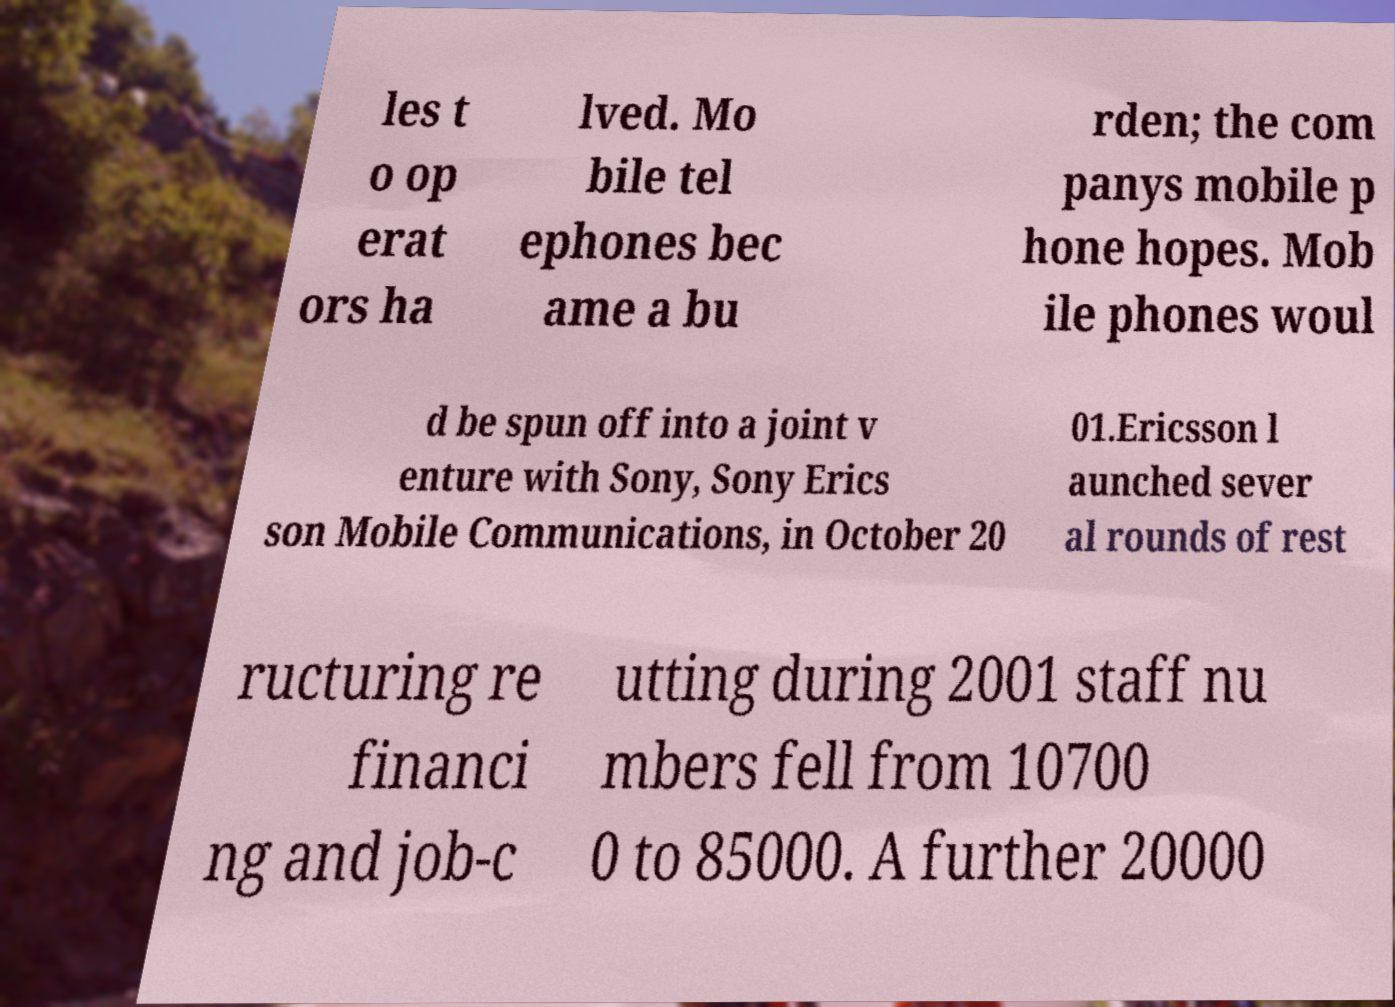Please identify and transcribe the text found in this image. les t o op erat ors ha lved. Mo bile tel ephones bec ame a bu rden; the com panys mobile p hone hopes. Mob ile phones woul d be spun off into a joint v enture with Sony, Sony Erics son Mobile Communications, in October 20 01.Ericsson l aunched sever al rounds of rest ructuring re financi ng and job-c utting during 2001 staff nu mbers fell from 10700 0 to 85000. A further 20000 